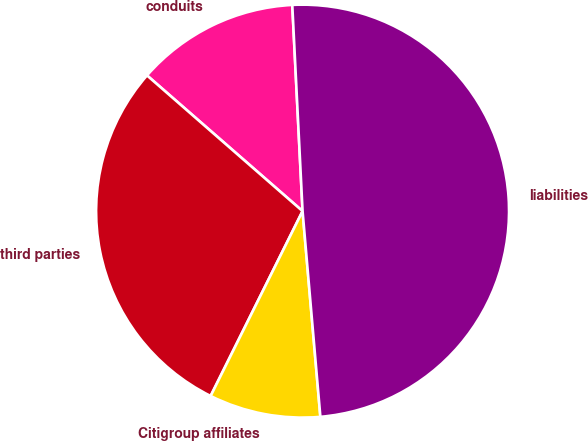Convert chart. <chart><loc_0><loc_0><loc_500><loc_500><pie_chart><fcel>conduits<fcel>third parties<fcel>Citigroup affiliates<fcel>liabilities<nl><fcel>12.79%<fcel>29.07%<fcel>8.72%<fcel>49.42%<nl></chart> 